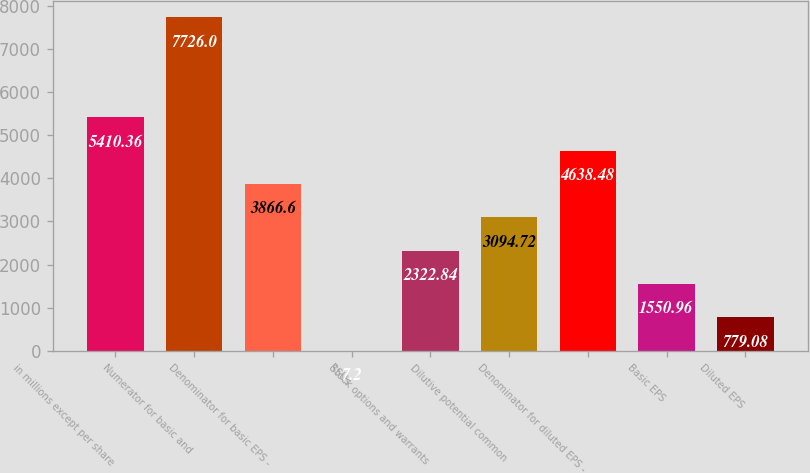Convert chart to OTSL. <chart><loc_0><loc_0><loc_500><loc_500><bar_chart><fcel>in millions except per share<fcel>Numerator for basic and<fcel>Denominator for basic EPS -<fcel>RSUs<fcel>Stock options and warrants<fcel>Dilutive potential common<fcel>Denominator for diluted EPS -<fcel>Basic EPS<fcel>Diluted EPS<nl><fcel>5410.36<fcel>7726<fcel>3866.6<fcel>7.2<fcel>2322.84<fcel>3094.72<fcel>4638.48<fcel>1550.96<fcel>779.08<nl></chart> 